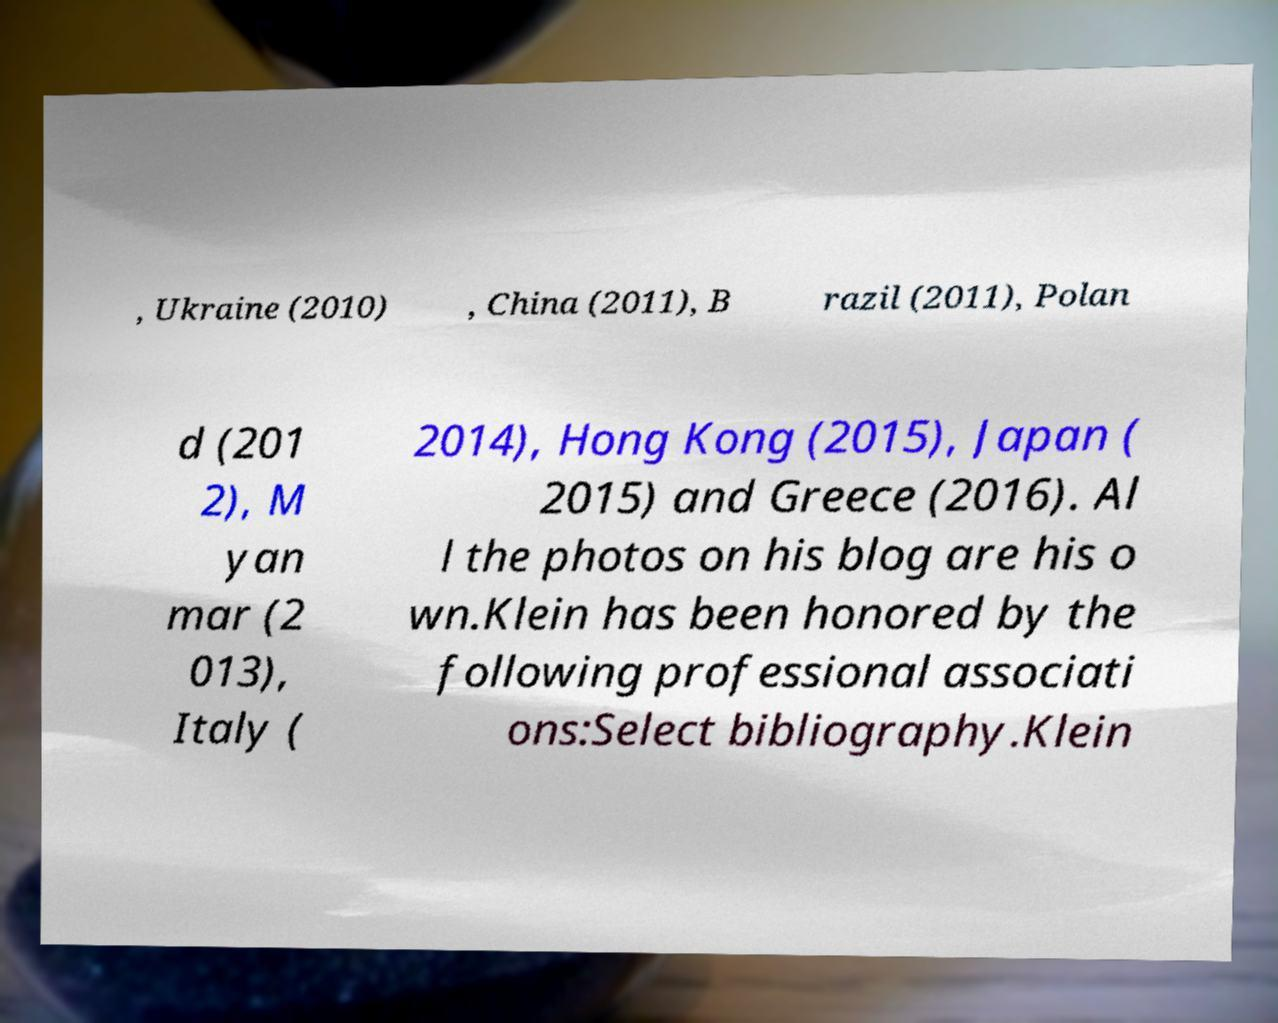Can you read and provide the text displayed in the image?This photo seems to have some interesting text. Can you extract and type it out for me? , Ukraine (2010) , China (2011), B razil (2011), Polan d (201 2), M yan mar (2 013), Italy ( 2014), Hong Kong (2015), Japan ( 2015) and Greece (2016). Al l the photos on his blog are his o wn.Klein has been honored by the following professional associati ons:Select bibliography.Klein 